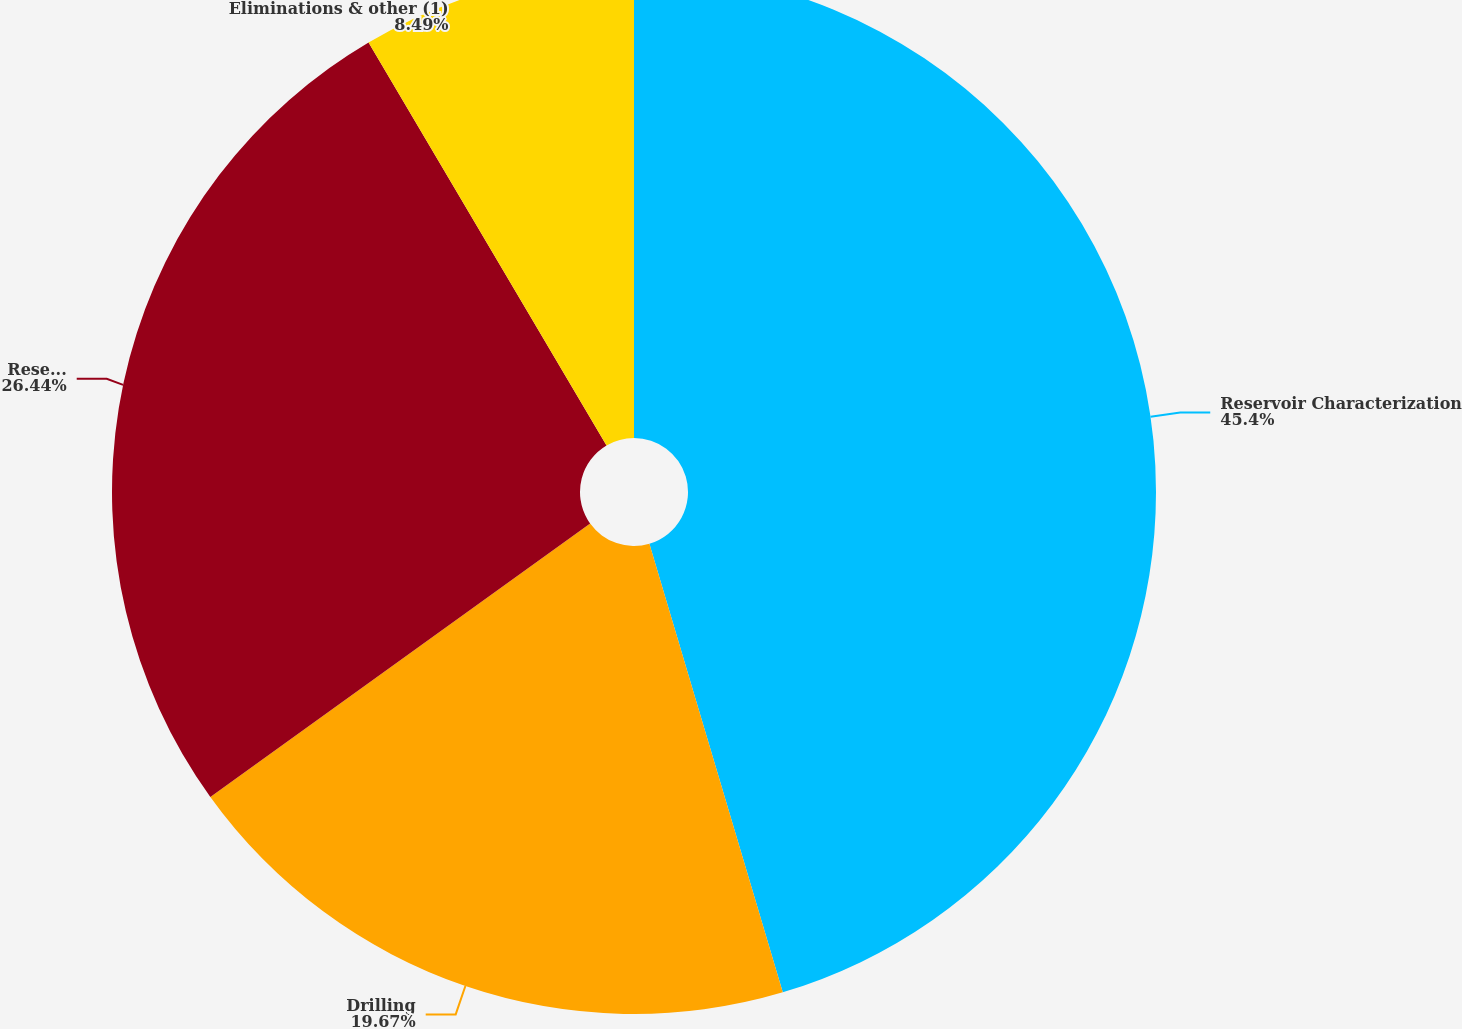<chart> <loc_0><loc_0><loc_500><loc_500><pie_chart><fcel>Reservoir Characterization<fcel>Drilling<fcel>Reservoir Production<fcel>Eliminations & other (1)<nl><fcel>45.4%<fcel>19.67%<fcel>26.44%<fcel>8.49%<nl></chart> 